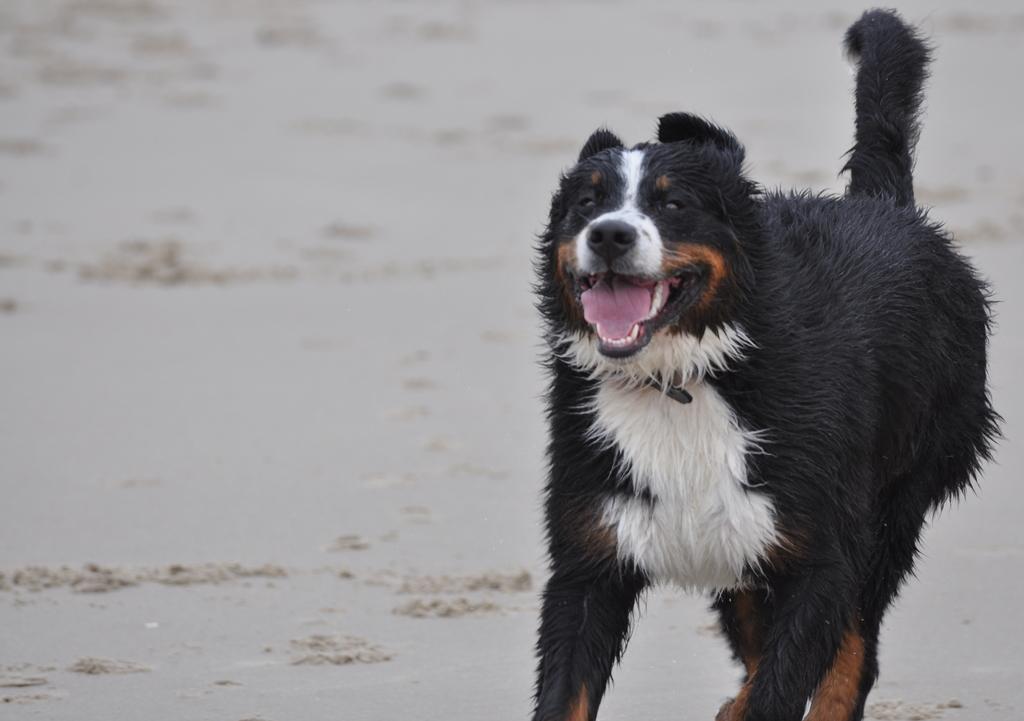Please provide a concise description of this image. In this image we can see a dog standing on the ground. 